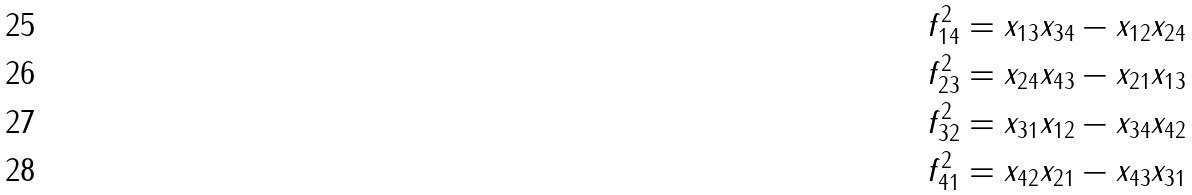<formula> <loc_0><loc_0><loc_500><loc_500>f _ { 1 4 } ^ { 2 } & = x _ { 1 3 } x _ { 3 4 } - x _ { 1 2 } x _ { 2 4 } \\ f _ { 2 3 } ^ { 2 } & = x _ { 2 4 } x _ { 4 3 } - x _ { 2 1 } x _ { 1 3 } \\ f _ { 3 2 } ^ { 2 } & = x _ { 3 1 } x _ { 1 2 } - x _ { 3 4 } x _ { 4 2 } \\ f _ { 4 1 } ^ { 2 } & = x _ { 4 2 } x _ { 2 1 } - x _ { 4 3 } x _ { 3 1 }</formula> 